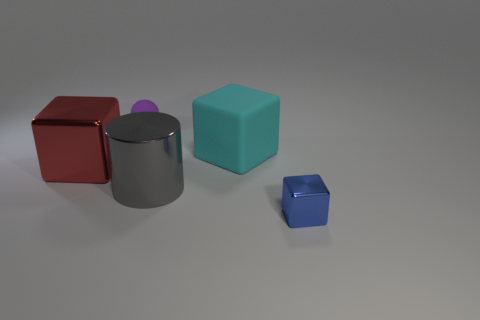There is a red thing that is the same size as the gray cylinder; what material is it?
Offer a very short reply. Metal. Are there any large gray cylinders that have the same material as the blue thing?
Offer a terse response. Yes. What is the color of the large block to the left of the tiny object behind the blue metal cube right of the tiny sphere?
Make the answer very short. Red. Are there any other things that have the same color as the big rubber block?
Ensure brevity in your answer.  No. Are there fewer metallic objects on the left side of the cyan matte block than big blocks?
Offer a very short reply. No. What number of cyan matte balls are there?
Provide a succinct answer. 0. Do the tiny blue object and the large metal thing that is on the right side of the purple matte object have the same shape?
Your response must be concise. No. Are there fewer metal things that are left of the tiny metal object than objects behind the gray shiny cylinder?
Ensure brevity in your answer.  Yes. Is there anything else that is the same shape as the purple matte object?
Offer a terse response. No. Is the red shiny object the same shape as the blue object?
Your response must be concise. Yes. 